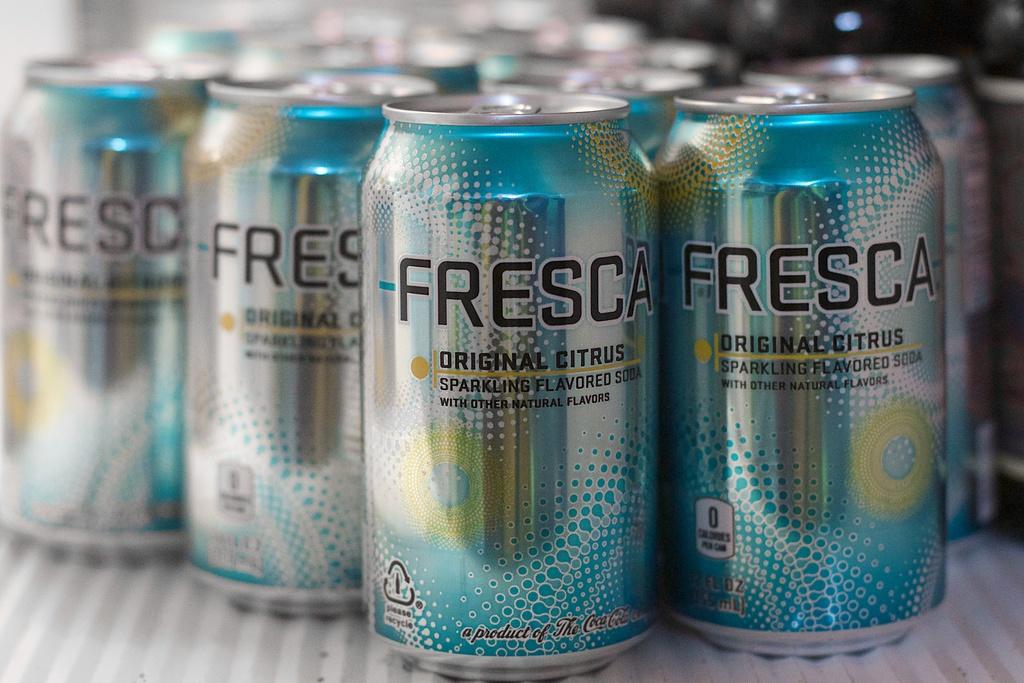What flavour is this drink?
Your answer should be compact. Original citrus. What brand is this?
Ensure brevity in your answer.  Fresca. 